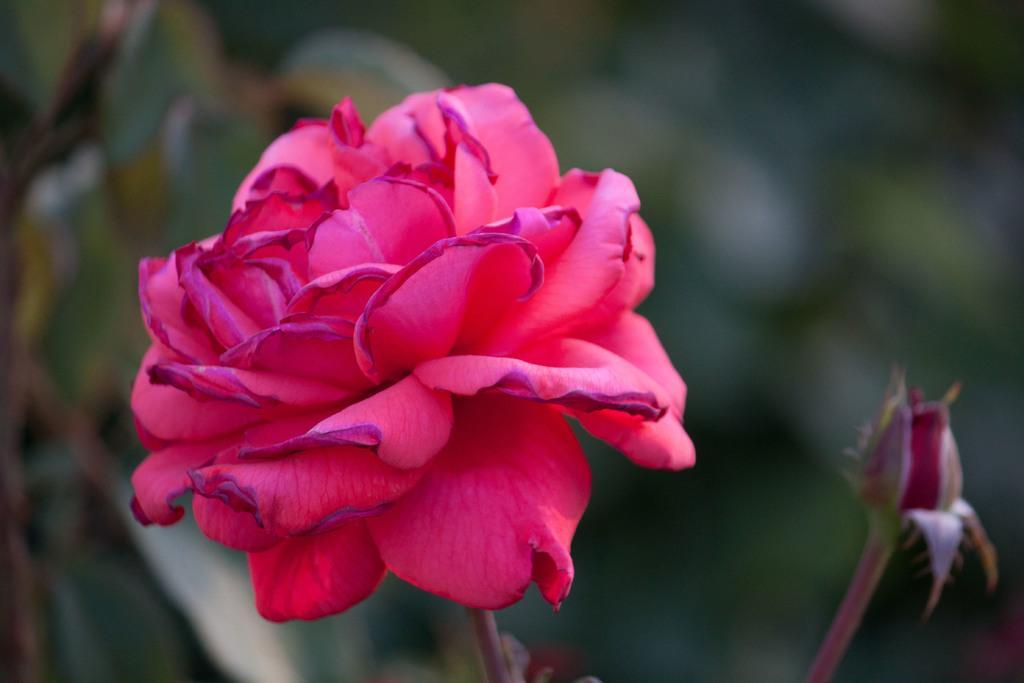Could you give a brief overview of what you see in this image? This image is taken outdoors. In this image the background is a little blurred. In the middle of the image there is a red rose and there is a bud. 